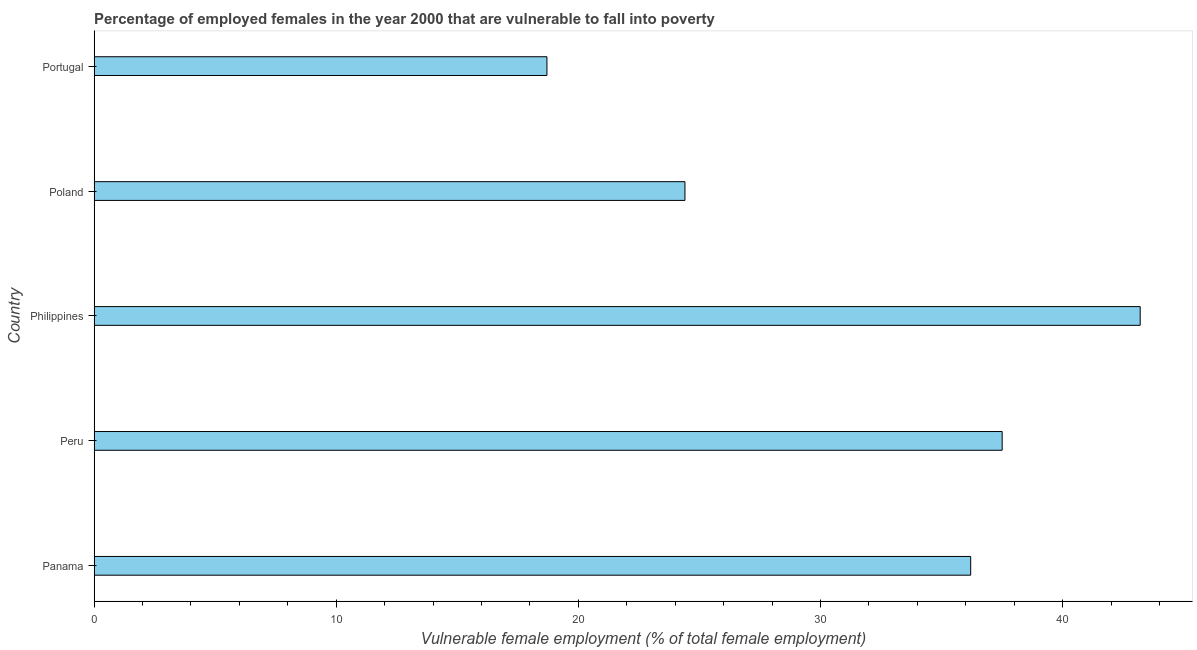Does the graph contain any zero values?
Give a very brief answer. No. What is the title of the graph?
Make the answer very short. Percentage of employed females in the year 2000 that are vulnerable to fall into poverty. What is the label or title of the X-axis?
Offer a very short reply. Vulnerable female employment (% of total female employment). What is the label or title of the Y-axis?
Your response must be concise. Country. What is the percentage of employed females who are vulnerable to fall into poverty in Portugal?
Keep it short and to the point. 18.7. Across all countries, what is the maximum percentage of employed females who are vulnerable to fall into poverty?
Give a very brief answer. 43.2. Across all countries, what is the minimum percentage of employed females who are vulnerable to fall into poverty?
Your answer should be compact. 18.7. In which country was the percentage of employed females who are vulnerable to fall into poverty maximum?
Your answer should be compact. Philippines. In which country was the percentage of employed females who are vulnerable to fall into poverty minimum?
Keep it short and to the point. Portugal. What is the sum of the percentage of employed females who are vulnerable to fall into poverty?
Your response must be concise. 160. What is the difference between the percentage of employed females who are vulnerable to fall into poverty in Philippines and Poland?
Provide a short and direct response. 18.8. What is the average percentage of employed females who are vulnerable to fall into poverty per country?
Provide a succinct answer. 32. What is the median percentage of employed females who are vulnerable to fall into poverty?
Your answer should be compact. 36.2. What is the ratio of the percentage of employed females who are vulnerable to fall into poverty in Panama to that in Portugal?
Offer a very short reply. 1.94. What is the difference between the highest and the lowest percentage of employed females who are vulnerable to fall into poverty?
Provide a short and direct response. 24.5. In how many countries, is the percentage of employed females who are vulnerable to fall into poverty greater than the average percentage of employed females who are vulnerable to fall into poverty taken over all countries?
Give a very brief answer. 3. How many countries are there in the graph?
Your answer should be very brief. 5. Are the values on the major ticks of X-axis written in scientific E-notation?
Your response must be concise. No. What is the Vulnerable female employment (% of total female employment) in Panama?
Offer a terse response. 36.2. What is the Vulnerable female employment (% of total female employment) in Peru?
Your answer should be very brief. 37.5. What is the Vulnerable female employment (% of total female employment) in Philippines?
Your answer should be compact. 43.2. What is the Vulnerable female employment (% of total female employment) in Poland?
Ensure brevity in your answer.  24.4. What is the Vulnerable female employment (% of total female employment) of Portugal?
Provide a succinct answer. 18.7. What is the difference between the Vulnerable female employment (% of total female employment) in Panama and Poland?
Provide a short and direct response. 11.8. What is the difference between the Vulnerable female employment (% of total female employment) in Peru and Philippines?
Your answer should be compact. -5.7. What is the difference between the Vulnerable female employment (% of total female employment) in Peru and Poland?
Give a very brief answer. 13.1. What is the difference between the Vulnerable female employment (% of total female employment) in Peru and Portugal?
Your answer should be very brief. 18.8. What is the difference between the Vulnerable female employment (% of total female employment) in Philippines and Poland?
Offer a terse response. 18.8. What is the ratio of the Vulnerable female employment (% of total female employment) in Panama to that in Philippines?
Your answer should be compact. 0.84. What is the ratio of the Vulnerable female employment (% of total female employment) in Panama to that in Poland?
Offer a terse response. 1.48. What is the ratio of the Vulnerable female employment (% of total female employment) in Panama to that in Portugal?
Give a very brief answer. 1.94. What is the ratio of the Vulnerable female employment (% of total female employment) in Peru to that in Philippines?
Provide a succinct answer. 0.87. What is the ratio of the Vulnerable female employment (% of total female employment) in Peru to that in Poland?
Your answer should be very brief. 1.54. What is the ratio of the Vulnerable female employment (% of total female employment) in Peru to that in Portugal?
Give a very brief answer. 2. What is the ratio of the Vulnerable female employment (% of total female employment) in Philippines to that in Poland?
Your answer should be compact. 1.77. What is the ratio of the Vulnerable female employment (% of total female employment) in Philippines to that in Portugal?
Offer a very short reply. 2.31. What is the ratio of the Vulnerable female employment (% of total female employment) in Poland to that in Portugal?
Provide a succinct answer. 1.3. 